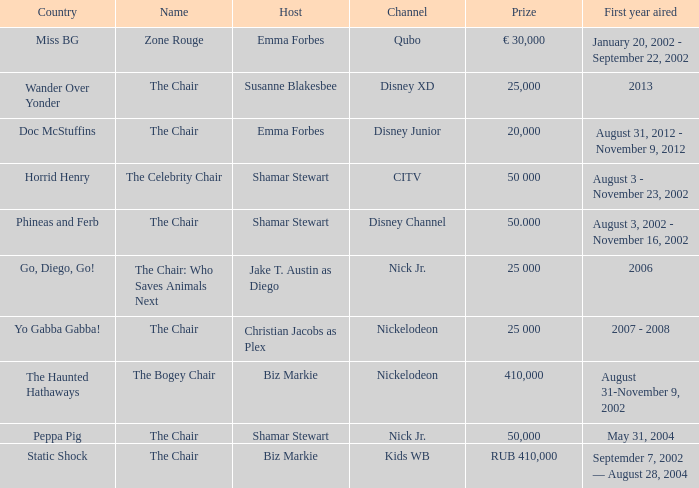What was the host of Horrid Henry? Shamar Stewart. 